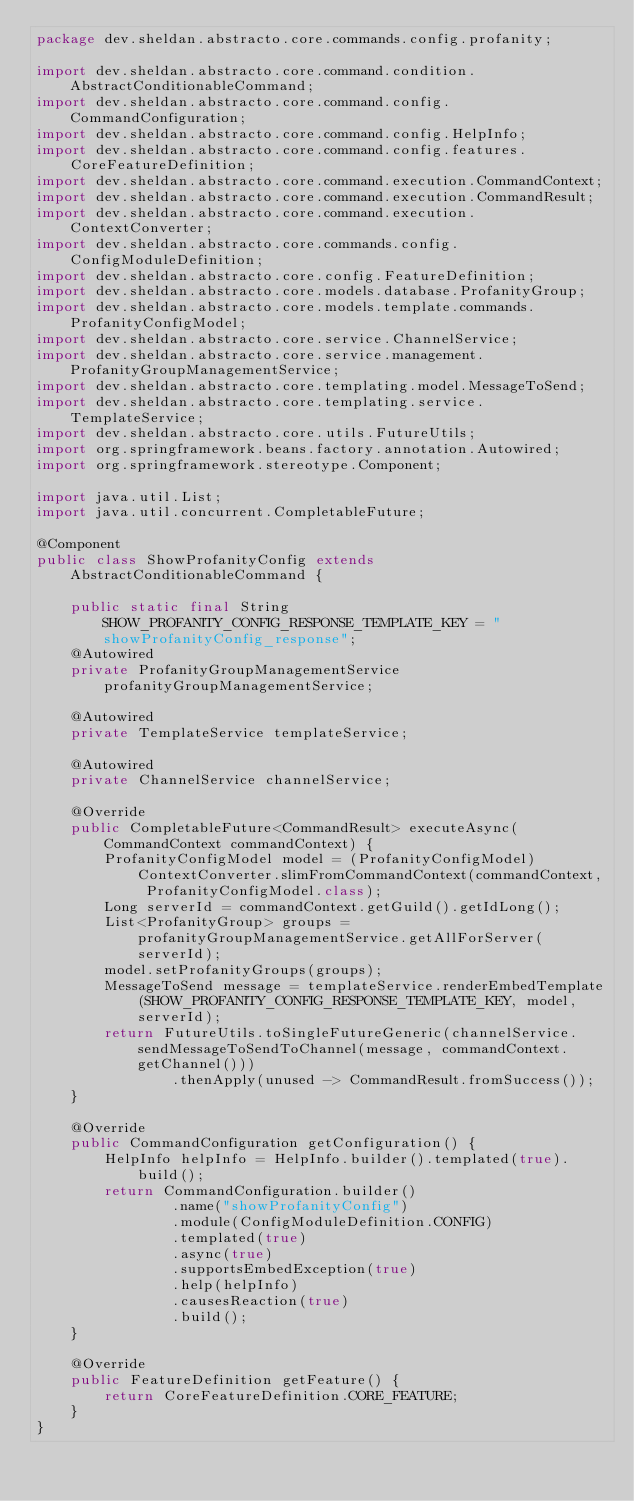Convert code to text. <code><loc_0><loc_0><loc_500><loc_500><_Java_>package dev.sheldan.abstracto.core.commands.config.profanity;

import dev.sheldan.abstracto.core.command.condition.AbstractConditionableCommand;
import dev.sheldan.abstracto.core.command.config.CommandConfiguration;
import dev.sheldan.abstracto.core.command.config.HelpInfo;
import dev.sheldan.abstracto.core.command.config.features.CoreFeatureDefinition;
import dev.sheldan.abstracto.core.command.execution.CommandContext;
import dev.sheldan.abstracto.core.command.execution.CommandResult;
import dev.sheldan.abstracto.core.command.execution.ContextConverter;
import dev.sheldan.abstracto.core.commands.config.ConfigModuleDefinition;
import dev.sheldan.abstracto.core.config.FeatureDefinition;
import dev.sheldan.abstracto.core.models.database.ProfanityGroup;
import dev.sheldan.abstracto.core.models.template.commands.ProfanityConfigModel;
import dev.sheldan.abstracto.core.service.ChannelService;
import dev.sheldan.abstracto.core.service.management.ProfanityGroupManagementService;
import dev.sheldan.abstracto.core.templating.model.MessageToSend;
import dev.sheldan.abstracto.core.templating.service.TemplateService;
import dev.sheldan.abstracto.core.utils.FutureUtils;
import org.springframework.beans.factory.annotation.Autowired;
import org.springframework.stereotype.Component;

import java.util.List;
import java.util.concurrent.CompletableFuture;

@Component
public class ShowProfanityConfig extends AbstractConditionableCommand {

    public static final String SHOW_PROFANITY_CONFIG_RESPONSE_TEMPLATE_KEY = "showProfanityConfig_response";
    @Autowired
    private ProfanityGroupManagementService profanityGroupManagementService;

    @Autowired
    private TemplateService templateService;

    @Autowired
    private ChannelService channelService;

    @Override
    public CompletableFuture<CommandResult> executeAsync(CommandContext commandContext) {
        ProfanityConfigModel model = (ProfanityConfigModel) ContextConverter.slimFromCommandContext(commandContext, ProfanityConfigModel.class);
        Long serverId = commandContext.getGuild().getIdLong();
        List<ProfanityGroup> groups = profanityGroupManagementService.getAllForServer(serverId);
        model.setProfanityGroups(groups);
        MessageToSend message = templateService.renderEmbedTemplate(SHOW_PROFANITY_CONFIG_RESPONSE_TEMPLATE_KEY, model, serverId);
        return FutureUtils.toSingleFutureGeneric(channelService.sendMessageToSendToChannel(message, commandContext.getChannel()))
                .thenApply(unused -> CommandResult.fromSuccess());
    }

    @Override
    public CommandConfiguration getConfiguration() {
        HelpInfo helpInfo = HelpInfo.builder().templated(true).build();
        return CommandConfiguration.builder()
                .name("showProfanityConfig")
                .module(ConfigModuleDefinition.CONFIG)
                .templated(true)
                .async(true)
                .supportsEmbedException(true)
                .help(helpInfo)
                .causesReaction(true)
                .build();
    }

    @Override
    public FeatureDefinition getFeature() {
        return CoreFeatureDefinition.CORE_FEATURE;
    }
}
</code> 